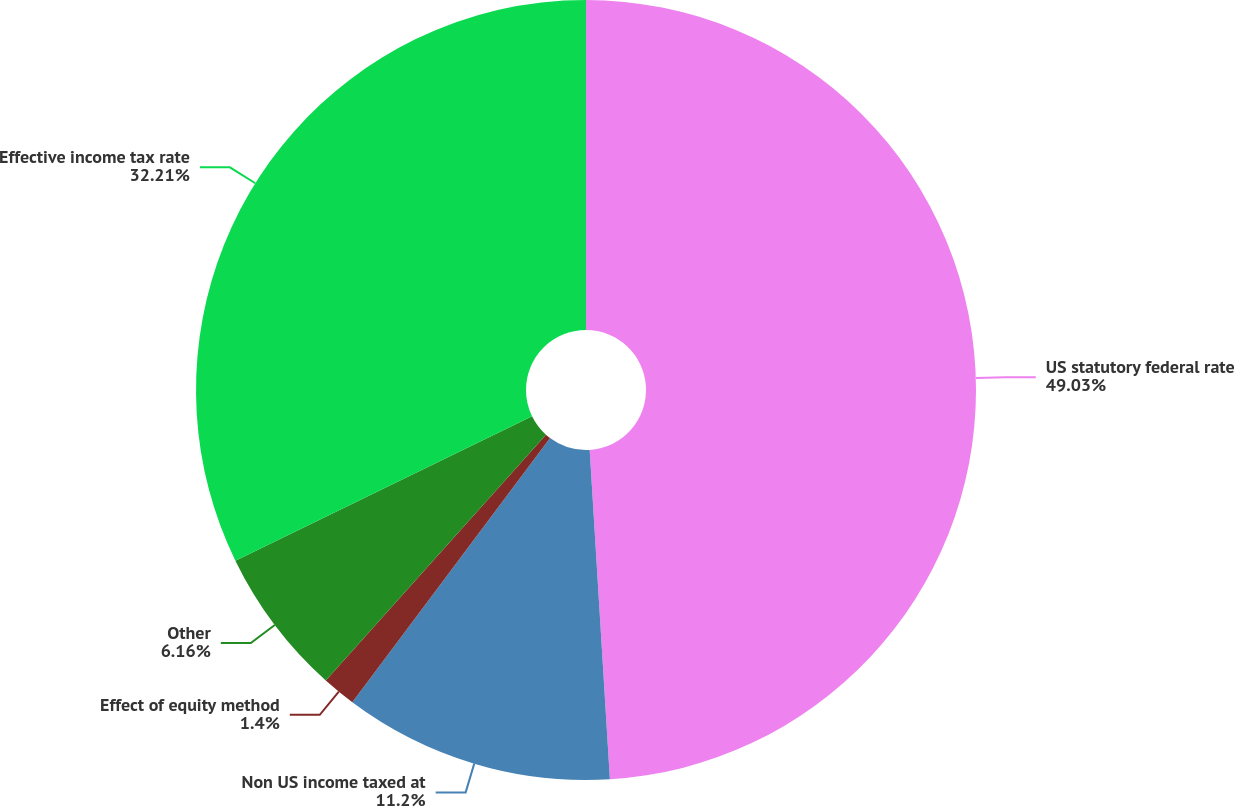<chart> <loc_0><loc_0><loc_500><loc_500><pie_chart><fcel>US statutory federal rate<fcel>Non US income taxed at<fcel>Effect of equity method<fcel>Other<fcel>Effective income tax rate<nl><fcel>49.02%<fcel>11.2%<fcel>1.4%<fcel>6.16%<fcel>32.21%<nl></chart> 